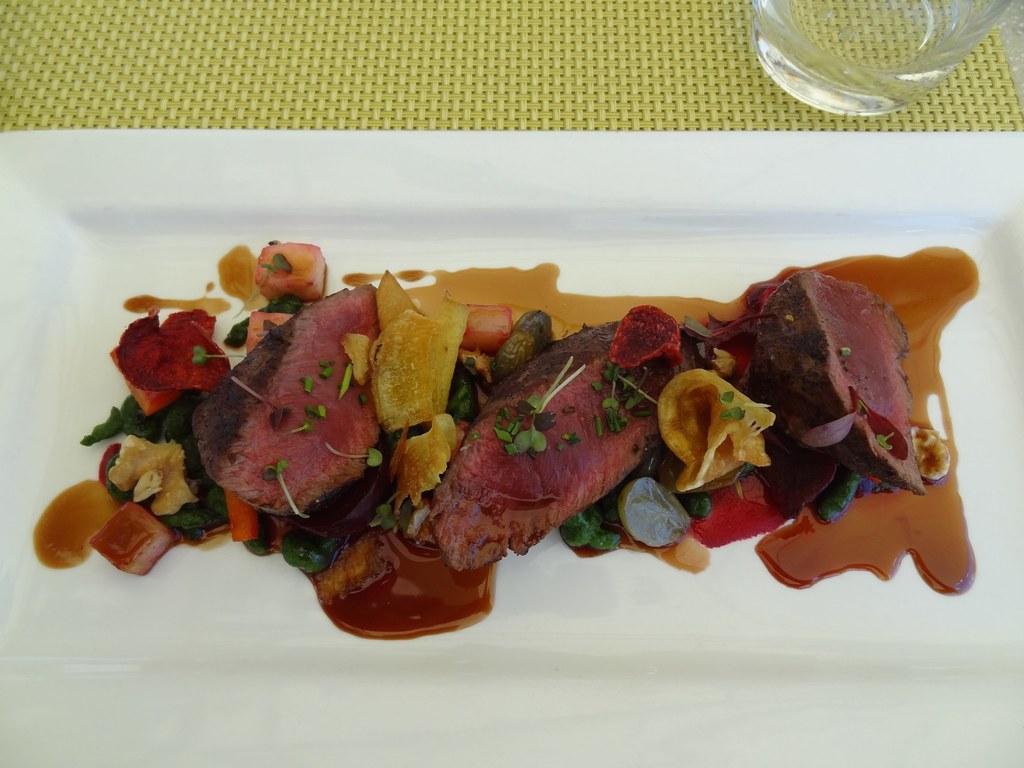Please provide a concise description of this image. Here we can see food items and soup in a plate on a platform and on the right at the top corner there is a glass on the platform. 